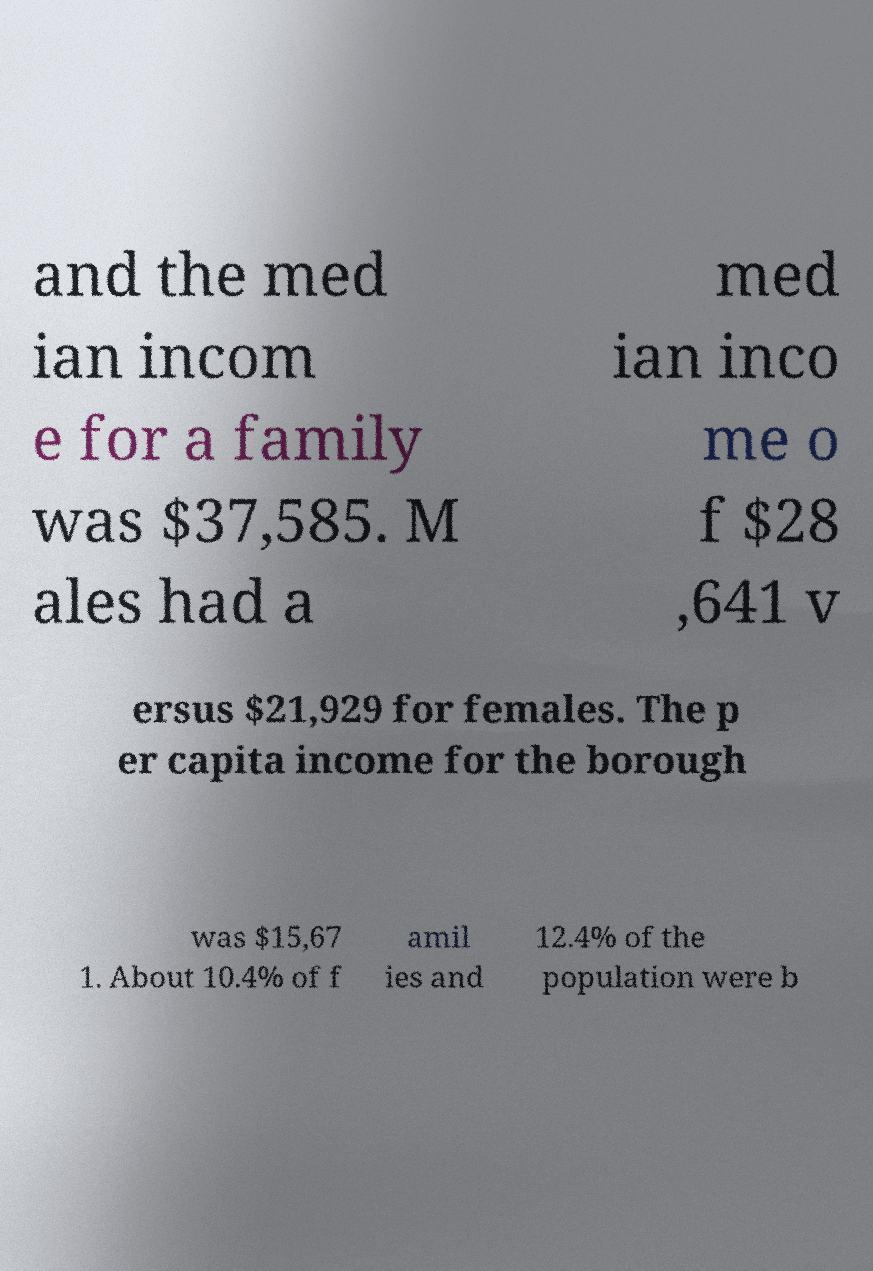Can you read and provide the text displayed in the image?This photo seems to have some interesting text. Can you extract and type it out for me? and the med ian incom e for a family was $37,585. M ales had a med ian inco me o f $28 ,641 v ersus $21,929 for females. The p er capita income for the borough was $15,67 1. About 10.4% of f amil ies and 12.4% of the population were b 